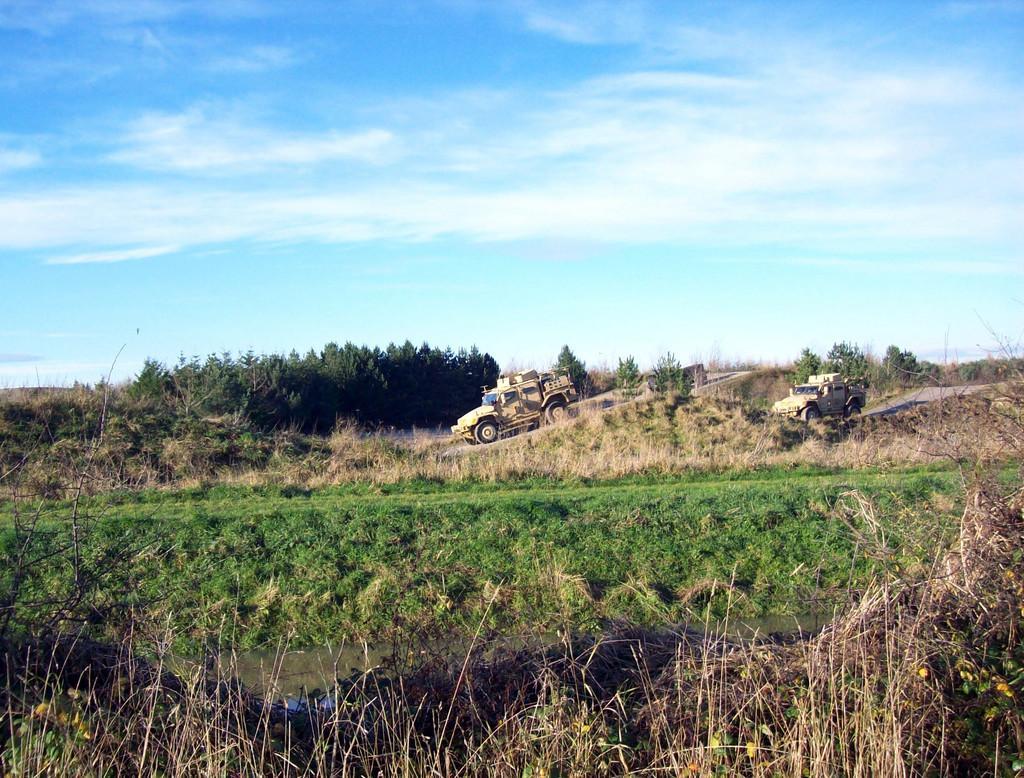Can you describe this image briefly? In this picture we can see few vehicles are on the road, around we can see so many trees and grass. 